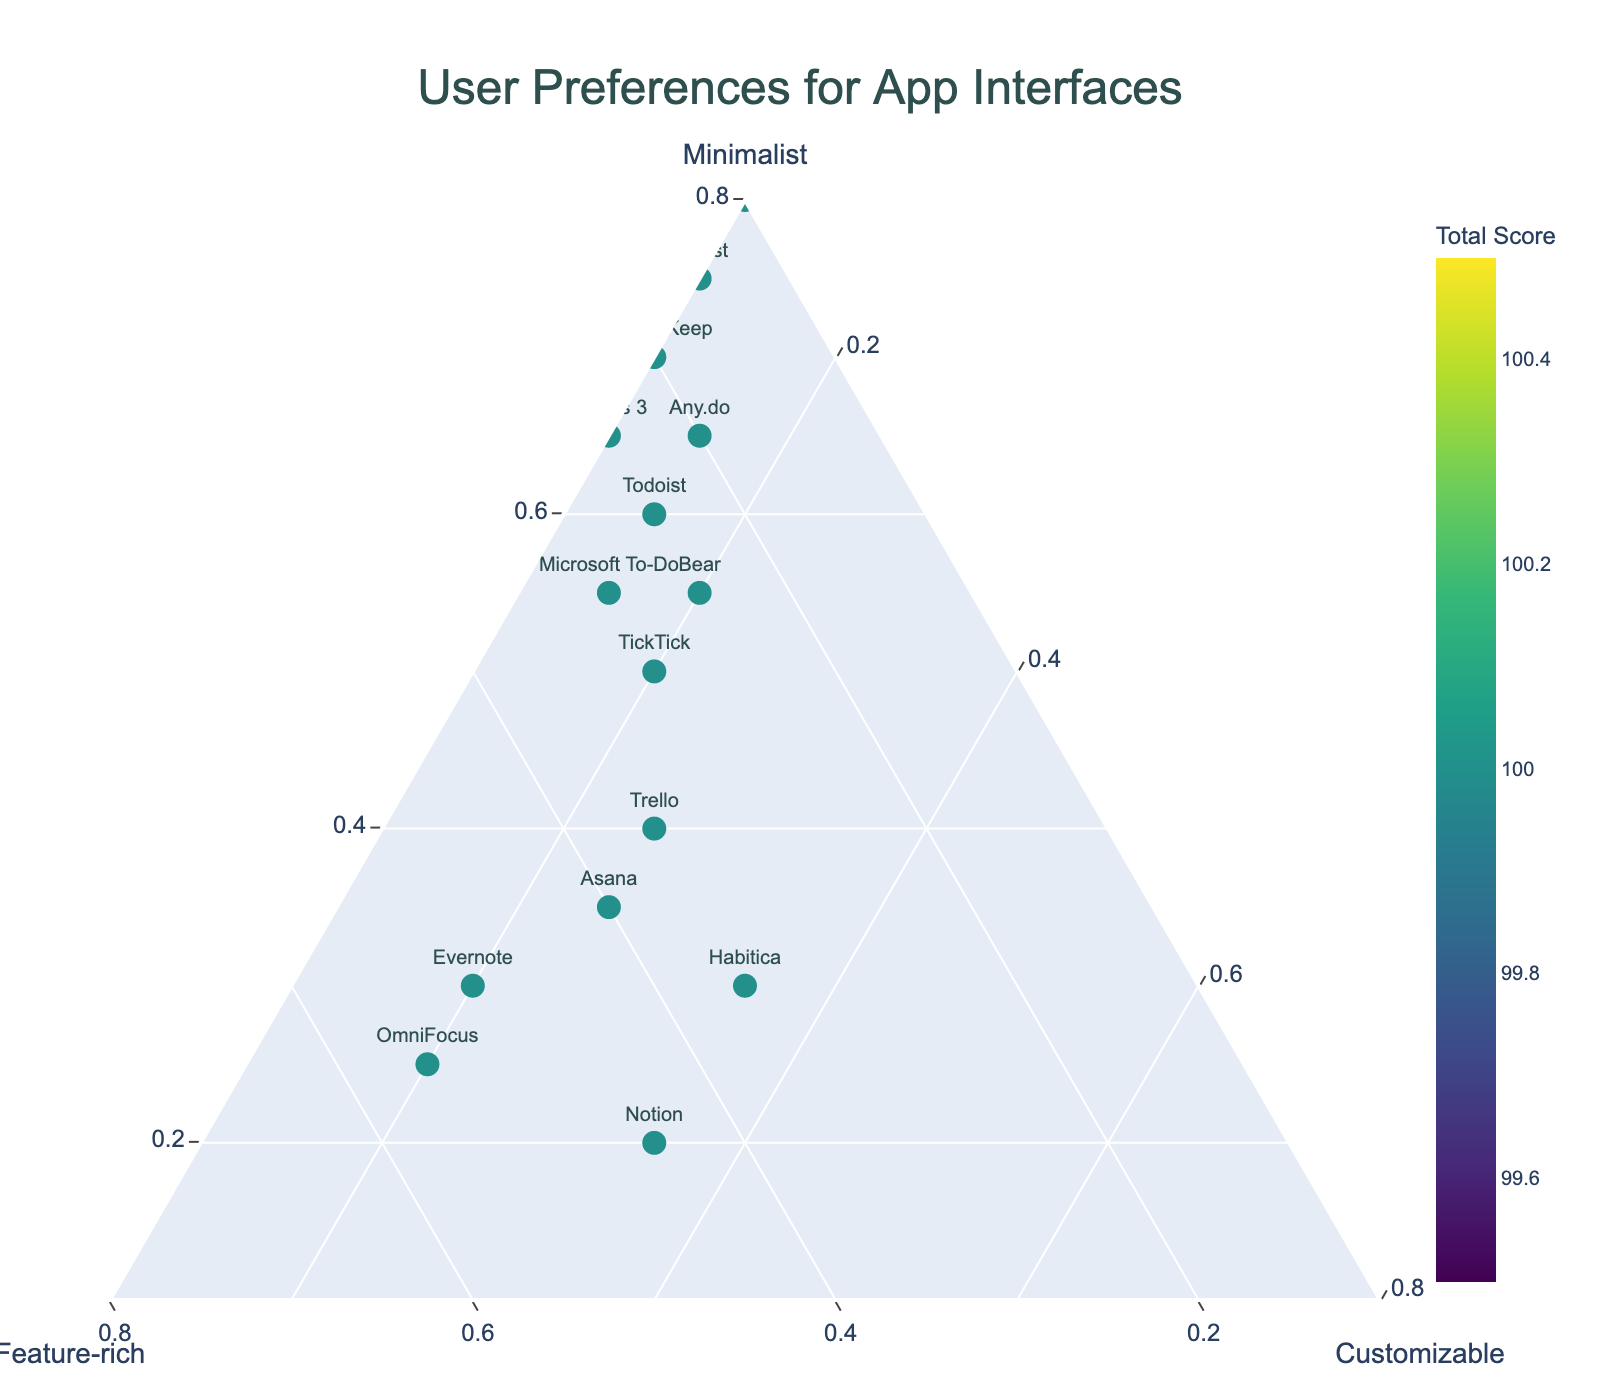what is the title of the plot? The title of the plot is located at the top center and reads "User Preferences for App Interfaces".
Answer: User Preferences for App Interfaces Which app has the highest preference for the "Minimalist" interface? On the plot, the preference for the "Minimalist" interface can be identified along the "Minimalist" axis. The app with the highest value on this axis is Simplenote.
Answer: Simplenote What is the sum of all three types of preferences for Todoist? Todoist shows 60 for "Minimalist", 25 for "Feature-rich", and 15 for "Customizable". Adding these values: 60 + 25 + 15 = 100.
Answer: 100 Compare Google Keep and Forest in terms of "Feature-rich" preference. Which one is preferred more for this category? By looking at the values along the "Feature-rich" axis, Forest has a "Feature-rich" preference of 15%, whereas Google Keep has a value of 20%. Thus, Google Keep is preferred more in this category.
Answer: Google Keep Which apps are equally preferred for the "Customizable" interface? On the plot, by focusing on the "Customizable" axis, identify the apps with the same value. Todoist, Microsoft To-Do, Any.do, and Bear all have a "Customizable" value of 15%.
Answer: Todoist, Microsoft To-Do, Any.do, Bear Is there any app that scores equally across all three preference categories? On the ternary plot, an app that has equal preference across "Minimalist", "Feature-rich", and "Customizable" would be situated at the center. By checking the data points, no app is located centrally.
Answer: No What is the total score for TickTick, and how does it compare to Trello's total score? TickTick has scores of 50 for "Minimalist", 30 for "Feature-rich", and 20 for "Customizable", adding up to 100. Trello has values of 40, 35, and 25, which sum to the same total score of 100.
Answer: Same Which app is the closest to an equal distribution between "Minimalist", "Feature-rich", and "Customizable"? On a ternary plot, an app with an equal distribution would be near the center. Habitica appears closest to the center with values of 30%, 35%, and 35%.
Answer: Habitica What is the percentage preference for the "Customizable" interface for Evernote, and how does it compare to Asana? Evernote has a preference of 20% for "Customizable", whereas Asana has 25%. Asana has a higher percentage preference for the "Customizable" interface.
Answer: Asana How do the overall preferences for "Minimalist" and "Feature-rich" interfaces compare across all apps? To compare overall preferences, count the higher preference values for "Minimalist" and "Feature-rich" interfaces. More apps (Todoist, Microsoft To-Do, Any.do, Google Keep, Forest, Simplenote, Things 3) have "Minimalist" as their highest preference compared to "Feature-rich" (Evernote, OmniFocus).
Answer: "Minimalist" is generally preferred more 